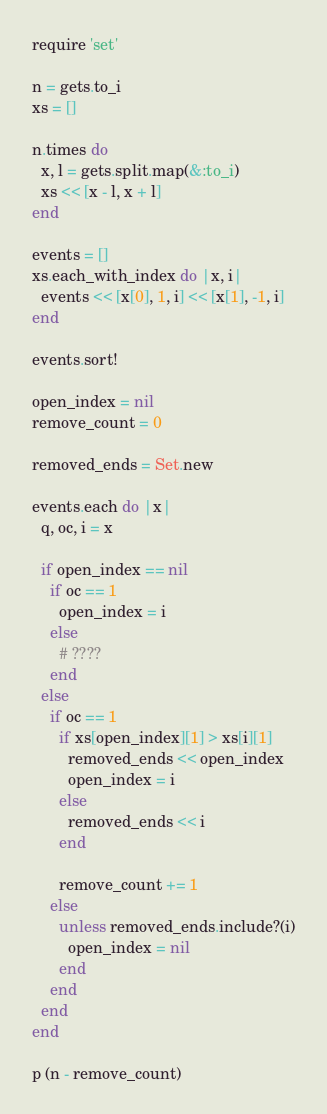<code> <loc_0><loc_0><loc_500><loc_500><_Ruby_>require 'set'

n = gets.to_i
xs = []

n.times do
  x, l = gets.split.map(&:to_i)
  xs << [x - l, x + l]
end

events = []
xs.each_with_index do |x, i|
  events << [x[0], 1, i] << [x[1], -1, i]
end

events.sort!

open_index = nil
remove_count = 0

removed_ends = Set.new

events.each do |x|
  q, oc, i = x

  if open_index == nil
    if oc == 1
      open_index = i
    else
      # ????
    end
  else
    if oc == 1
      if xs[open_index][1] > xs[i][1]
        removed_ends << open_index
        open_index = i
      else
        removed_ends << i
      end

      remove_count += 1
    else
      unless removed_ends.include?(i)
        open_index = nil
      end
    end
  end
end

p (n - remove_count)
</code> 